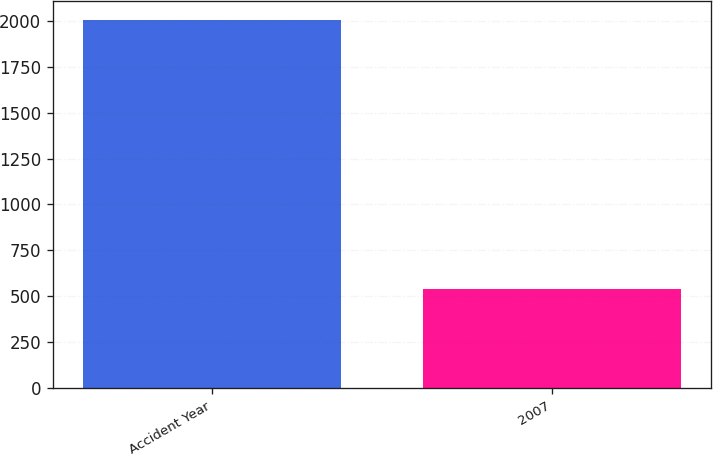Convert chart to OTSL. <chart><loc_0><loc_0><loc_500><loc_500><bar_chart><fcel>Accident Year<fcel>2007<nl><fcel>2008<fcel>537<nl></chart> 